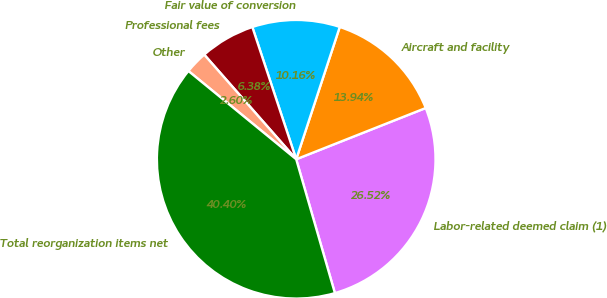<chart> <loc_0><loc_0><loc_500><loc_500><pie_chart><fcel>Labor-related deemed claim (1)<fcel>Aircraft and facility<fcel>Fair value of conversion<fcel>Professional fees<fcel>Other<fcel>Total reorganization items net<nl><fcel>26.52%<fcel>13.94%<fcel>10.16%<fcel>6.38%<fcel>2.6%<fcel>40.4%<nl></chart> 